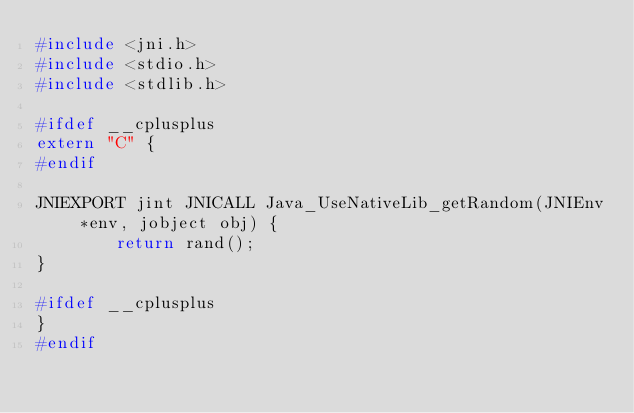<code> <loc_0><loc_0><loc_500><loc_500><_C_>#include <jni.h>
#include <stdio.h>
#include <stdlib.h>

#ifdef __cplusplus
extern "C" {
#endif

JNIEXPORT jint JNICALL Java_UseNativeLib_getRandom(JNIEnv *env, jobject obj) {
        return rand();
}

#ifdef __cplusplus
}
#endif
</code> 